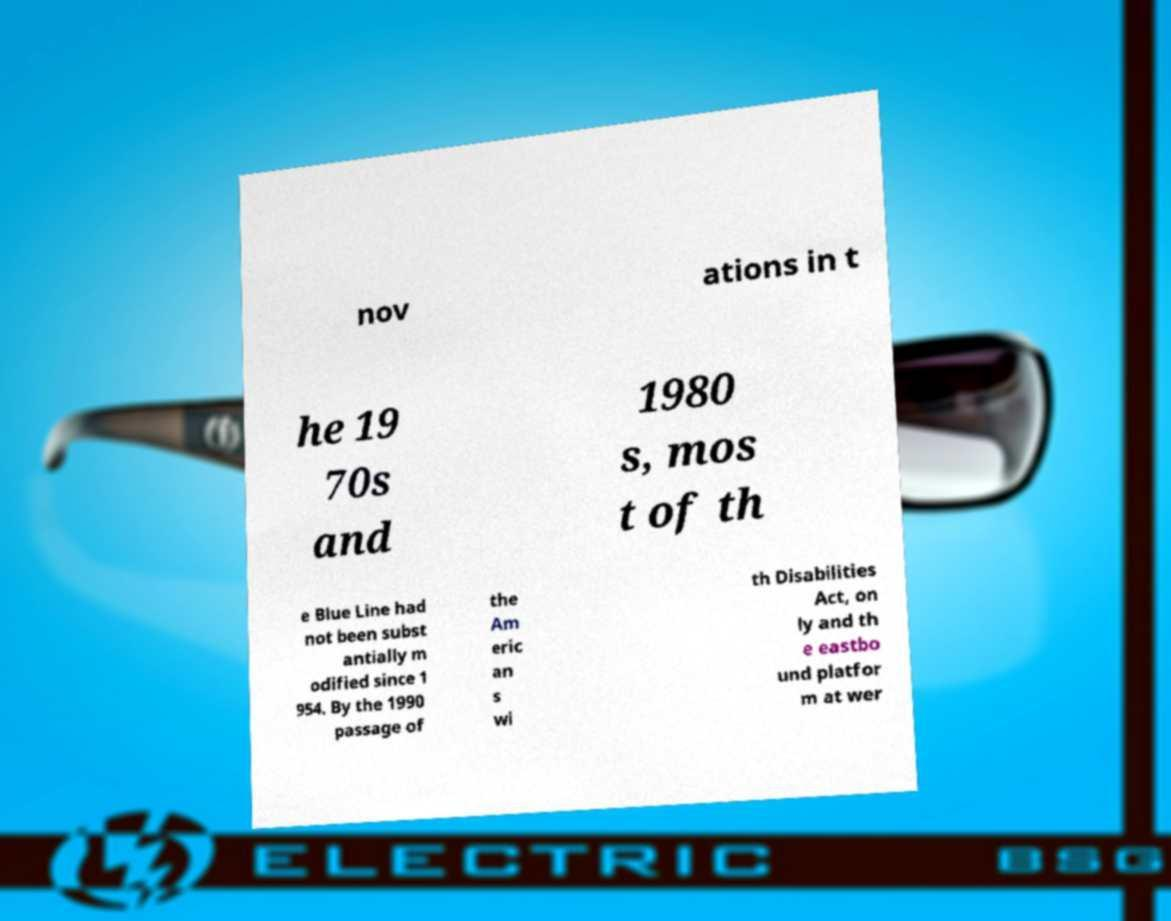What messages or text are displayed in this image? I need them in a readable, typed format. nov ations in t he 19 70s and 1980 s, mos t of th e Blue Line had not been subst antially m odified since 1 954. By the 1990 passage of the Am eric an s wi th Disabilities Act, on ly and th e eastbo und platfor m at wer 